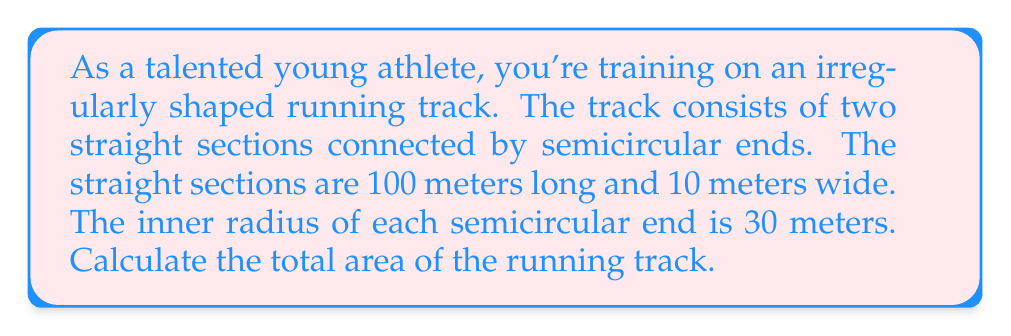Solve this math problem. Let's break this down step-by-step:

1) First, we need to calculate the area of the straight sections:
   - Each straight section is a rectangle
   - Area of one straight section = $100 \text{ m} \times 10 \text{ m} = 1000 \text{ m}^2$
   - There are two straight sections, so total area = $2 \times 1000 = 2000 \text{ m}^2$

2) Now, let's calculate the area of the semicircular ends:
   - The inner radius is 30 m, but we need the outer radius
   - Outer radius = inner radius + width of track = $30 \text{ m} + 10 \text{ m} = 40 \text{ m}$
   - Area of a full circle = $\pi r^2$
   - Area of semicircle = $\frac{1}{2} \pi r^2$
   - Area of outer semicircle = $\frac{1}{2} \pi (40 \text{ m})^2 = 800\pi \text{ m}^2$
   - Area of inner semicircle = $\frac{1}{2} \pi (30 \text{ m})^2 = 450\pi \text{ m}^2$
   - Area of one semicircular end = $800\pi \text{ m}^2 - 450\pi \text{ m}^2 = 350\pi \text{ m}^2$
   - There are two semicircular ends, so total area = $2 \times 350\pi = 700\pi \text{ m}^2$

3) The total area of the track is the sum of the straight sections and the semicircular ends:
   Total area = $2000 \text{ m}^2 + 700\pi \text{ m}^2$

4) Simplifying:
   Total area $\approx 2000 + 2199.11 = 4199.11 \text{ m}^2$
Answer: $2000 + 700\pi \text{ m}^2$ or approximately $4199.11 \text{ m}^2$ 